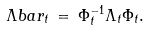Convert formula to latex. <formula><loc_0><loc_0><loc_500><loc_500>\Lambda b a r _ { t } \, = \, \Phi ^ { - 1 } _ { t } \Lambda _ { t } \Phi _ { t } .</formula> 